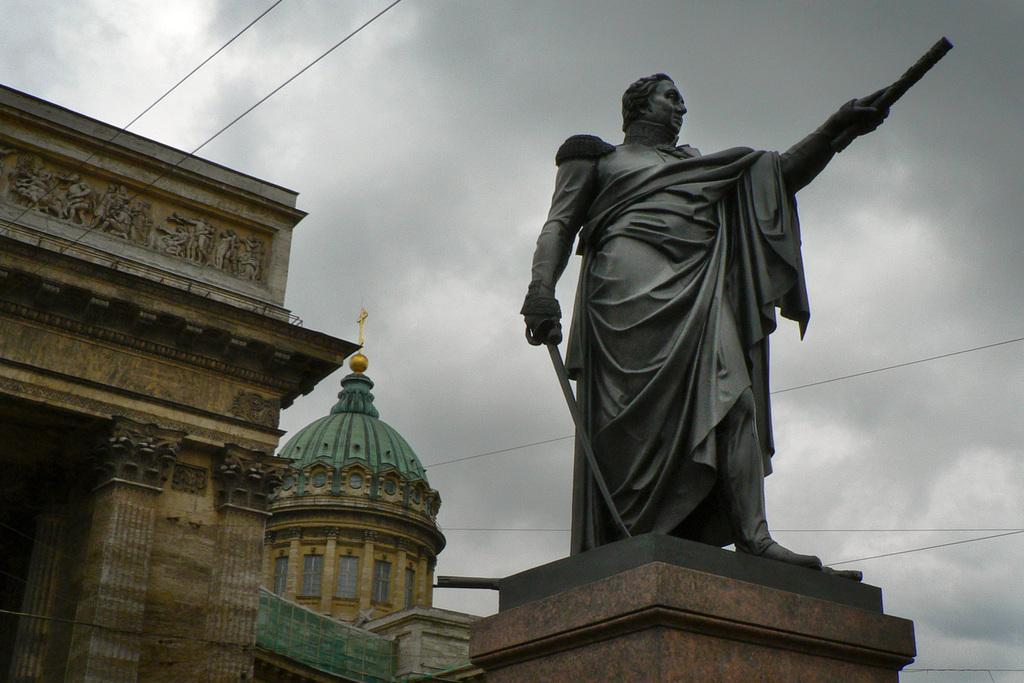What is the main subject of the image? There is a statue of a man in the image. What else can be seen in the image besides the statue? There are buildings and wires visible in the image. What is visible in the background of the image? The sky with clouds is visible in the background of the image. How many lizards are crawling on the statue in the image? There are no lizards present in the image; the statue is of a man. What time is displayed on the clock in the image? There is no clock present in the image; it features a statue, buildings, wires, and a sky with clouds. 